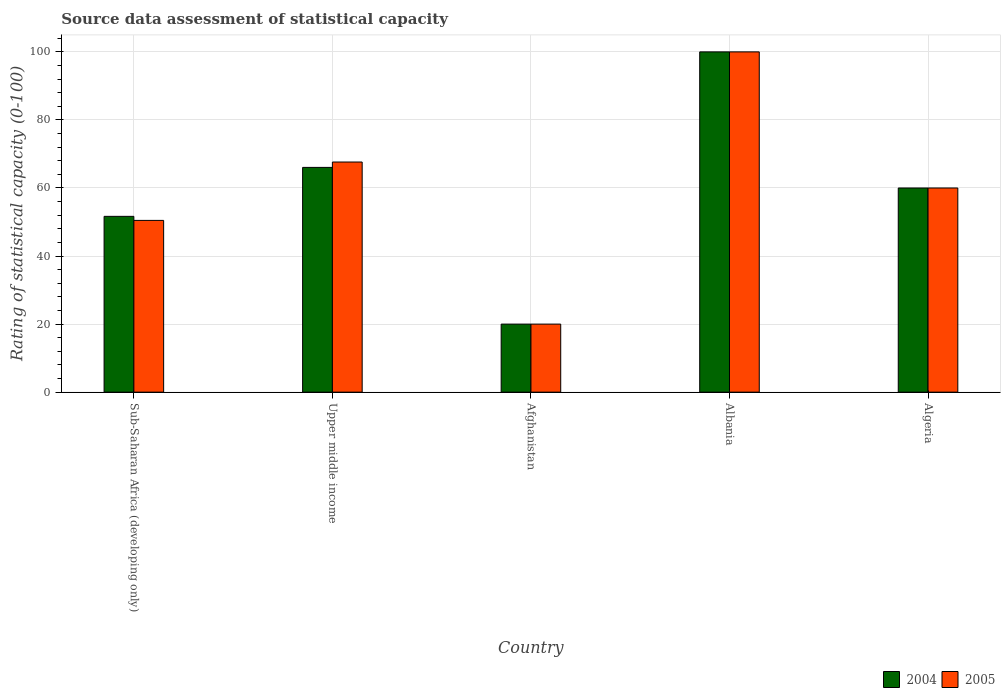How many bars are there on the 3rd tick from the left?
Your answer should be compact. 2. What is the label of the 4th group of bars from the left?
Ensure brevity in your answer.  Albania. What is the rating of statistical capacity in 2004 in Algeria?
Your response must be concise. 60. Across all countries, what is the maximum rating of statistical capacity in 2004?
Offer a terse response. 100. In which country was the rating of statistical capacity in 2004 maximum?
Make the answer very short. Albania. In which country was the rating of statistical capacity in 2005 minimum?
Offer a terse response. Afghanistan. What is the total rating of statistical capacity in 2004 in the graph?
Give a very brief answer. 297.72. What is the difference between the rating of statistical capacity in 2005 in Afghanistan and that in Algeria?
Your answer should be very brief. -40. What is the average rating of statistical capacity in 2004 per country?
Your answer should be compact. 59.54. In how many countries, is the rating of statistical capacity in 2005 greater than 12?
Provide a succinct answer. 5. What is the ratio of the rating of statistical capacity in 2005 in Afghanistan to that in Algeria?
Make the answer very short. 0.33. Is the difference between the rating of statistical capacity in 2005 in Sub-Saharan Africa (developing only) and Upper middle income greater than the difference between the rating of statistical capacity in 2004 in Sub-Saharan Africa (developing only) and Upper middle income?
Your response must be concise. No. What is the difference between the highest and the second highest rating of statistical capacity in 2004?
Offer a very short reply. -33.95. What is the difference between the highest and the lowest rating of statistical capacity in 2004?
Offer a terse response. 80. Is the sum of the rating of statistical capacity in 2004 in Algeria and Sub-Saharan Africa (developing only) greater than the maximum rating of statistical capacity in 2005 across all countries?
Ensure brevity in your answer.  Yes. What does the 1st bar from the left in Albania represents?
Keep it short and to the point. 2004. How many bars are there?
Ensure brevity in your answer.  10. How many countries are there in the graph?
Make the answer very short. 5. What is the difference between two consecutive major ticks on the Y-axis?
Give a very brief answer. 20. Does the graph contain grids?
Offer a very short reply. Yes. Where does the legend appear in the graph?
Keep it short and to the point. Bottom right. How are the legend labels stacked?
Your answer should be very brief. Horizontal. What is the title of the graph?
Keep it short and to the point. Source data assessment of statistical capacity. Does "1984" appear as one of the legend labels in the graph?
Ensure brevity in your answer.  No. What is the label or title of the X-axis?
Your answer should be compact. Country. What is the label or title of the Y-axis?
Keep it short and to the point. Rating of statistical capacity (0-100). What is the Rating of statistical capacity (0-100) of 2004 in Sub-Saharan Africa (developing only)?
Your answer should be very brief. 51.67. What is the Rating of statistical capacity (0-100) in 2005 in Sub-Saharan Africa (developing only)?
Offer a very short reply. 50.48. What is the Rating of statistical capacity (0-100) in 2004 in Upper middle income?
Provide a succinct answer. 66.05. What is the Rating of statistical capacity (0-100) in 2005 in Upper middle income?
Your answer should be very brief. 67.63. What is the Rating of statistical capacity (0-100) in 2004 in Afghanistan?
Your answer should be compact. 20. What is the Rating of statistical capacity (0-100) of 2005 in Afghanistan?
Offer a very short reply. 20. What is the Rating of statistical capacity (0-100) of 2004 in Algeria?
Make the answer very short. 60. Across all countries, what is the maximum Rating of statistical capacity (0-100) of 2004?
Ensure brevity in your answer.  100. Across all countries, what is the minimum Rating of statistical capacity (0-100) in 2004?
Offer a terse response. 20. Across all countries, what is the minimum Rating of statistical capacity (0-100) of 2005?
Your answer should be compact. 20. What is the total Rating of statistical capacity (0-100) in 2004 in the graph?
Provide a short and direct response. 297.72. What is the total Rating of statistical capacity (0-100) of 2005 in the graph?
Offer a terse response. 298.11. What is the difference between the Rating of statistical capacity (0-100) of 2004 in Sub-Saharan Africa (developing only) and that in Upper middle income?
Keep it short and to the point. -14.39. What is the difference between the Rating of statistical capacity (0-100) of 2005 in Sub-Saharan Africa (developing only) and that in Upper middle income?
Offer a terse response. -17.16. What is the difference between the Rating of statistical capacity (0-100) in 2004 in Sub-Saharan Africa (developing only) and that in Afghanistan?
Your answer should be compact. 31.67. What is the difference between the Rating of statistical capacity (0-100) of 2005 in Sub-Saharan Africa (developing only) and that in Afghanistan?
Offer a terse response. 30.48. What is the difference between the Rating of statistical capacity (0-100) of 2004 in Sub-Saharan Africa (developing only) and that in Albania?
Your response must be concise. -48.33. What is the difference between the Rating of statistical capacity (0-100) in 2005 in Sub-Saharan Africa (developing only) and that in Albania?
Provide a short and direct response. -49.52. What is the difference between the Rating of statistical capacity (0-100) in 2004 in Sub-Saharan Africa (developing only) and that in Algeria?
Your answer should be very brief. -8.33. What is the difference between the Rating of statistical capacity (0-100) in 2005 in Sub-Saharan Africa (developing only) and that in Algeria?
Provide a short and direct response. -9.52. What is the difference between the Rating of statistical capacity (0-100) in 2004 in Upper middle income and that in Afghanistan?
Give a very brief answer. 46.05. What is the difference between the Rating of statistical capacity (0-100) of 2005 in Upper middle income and that in Afghanistan?
Provide a succinct answer. 47.63. What is the difference between the Rating of statistical capacity (0-100) in 2004 in Upper middle income and that in Albania?
Keep it short and to the point. -33.95. What is the difference between the Rating of statistical capacity (0-100) in 2005 in Upper middle income and that in Albania?
Your response must be concise. -32.37. What is the difference between the Rating of statistical capacity (0-100) of 2004 in Upper middle income and that in Algeria?
Offer a very short reply. 6.05. What is the difference between the Rating of statistical capacity (0-100) of 2005 in Upper middle income and that in Algeria?
Keep it short and to the point. 7.63. What is the difference between the Rating of statistical capacity (0-100) in 2004 in Afghanistan and that in Albania?
Make the answer very short. -80. What is the difference between the Rating of statistical capacity (0-100) of 2005 in Afghanistan and that in Albania?
Keep it short and to the point. -80. What is the difference between the Rating of statistical capacity (0-100) of 2004 in Afghanistan and that in Algeria?
Keep it short and to the point. -40. What is the difference between the Rating of statistical capacity (0-100) in 2004 in Albania and that in Algeria?
Your answer should be very brief. 40. What is the difference between the Rating of statistical capacity (0-100) of 2005 in Albania and that in Algeria?
Your answer should be very brief. 40. What is the difference between the Rating of statistical capacity (0-100) in 2004 in Sub-Saharan Africa (developing only) and the Rating of statistical capacity (0-100) in 2005 in Upper middle income?
Your response must be concise. -15.96. What is the difference between the Rating of statistical capacity (0-100) of 2004 in Sub-Saharan Africa (developing only) and the Rating of statistical capacity (0-100) of 2005 in Afghanistan?
Give a very brief answer. 31.67. What is the difference between the Rating of statistical capacity (0-100) in 2004 in Sub-Saharan Africa (developing only) and the Rating of statistical capacity (0-100) in 2005 in Albania?
Your answer should be very brief. -48.33. What is the difference between the Rating of statistical capacity (0-100) of 2004 in Sub-Saharan Africa (developing only) and the Rating of statistical capacity (0-100) of 2005 in Algeria?
Offer a terse response. -8.33. What is the difference between the Rating of statistical capacity (0-100) of 2004 in Upper middle income and the Rating of statistical capacity (0-100) of 2005 in Afghanistan?
Keep it short and to the point. 46.05. What is the difference between the Rating of statistical capacity (0-100) in 2004 in Upper middle income and the Rating of statistical capacity (0-100) in 2005 in Albania?
Provide a succinct answer. -33.95. What is the difference between the Rating of statistical capacity (0-100) in 2004 in Upper middle income and the Rating of statistical capacity (0-100) in 2005 in Algeria?
Offer a terse response. 6.05. What is the difference between the Rating of statistical capacity (0-100) of 2004 in Afghanistan and the Rating of statistical capacity (0-100) of 2005 in Albania?
Keep it short and to the point. -80. What is the difference between the Rating of statistical capacity (0-100) of 2004 in Afghanistan and the Rating of statistical capacity (0-100) of 2005 in Algeria?
Provide a succinct answer. -40. What is the difference between the Rating of statistical capacity (0-100) of 2004 in Albania and the Rating of statistical capacity (0-100) of 2005 in Algeria?
Provide a succinct answer. 40. What is the average Rating of statistical capacity (0-100) in 2004 per country?
Your response must be concise. 59.54. What is the average Rating of statistical capacity (0-100) in 2005 per country?
Provide a short and direct response. 59.62. What is the difference between the Rating of statistical capacity (0-100) in 2004 and Rating of statistical capacity (0-100) in 2005 in Sub-Saharan Africa (developing only)?
Your answer should be compact. 1.19. What is the difference between the Rating of statistical capacity (0-100) in 2004 and Rating of statistical capacity (0-100) in 2005 in Upper middle income?
Your answer should be very brief. -1.58. What is the difference between the Rating of statistical capacity (0-100) in 2004 and Rating of statistical capacity (0-100) in 2005 in Afghanistan?
Your response must be concise. 0. What is the difference between the Rating of statistical capacity (0-100) of 2004 and Rating of statistical capacity (0-100) of 2005 in Albania?
Offer a terse response. 0. What is the ratio of the Rating of statistical capacity (0-100) of 2004 in Sub-Saharan Africa (developing only) to that in Upper middle income?
Give a very brief answer. 0.78. What is the ratio of the Rating of statistical capacity (0-100) in 2005 in Sub-Saharan Africa (developing only) to that in Upper middle income?
Offer a very short reply. 0.75. What is the ratio of the Rating of statistical capacity (0-100) of 2004 in Sub-Saharan Africa (developing only) to that in Afghanistan?
Ensure brevity in your answer.  2.58. What is the ratio of the Rating of statistical capacity (0-100) in 2005 in Sub-Saharan Africa (developing only) to that in Afghanistan?
Ensure brevity in your answer.  2.52. What is the ratio of the Rating of statistical capacity (0-100) in 2004 in Sub-Saharan Africa (developing only) to that in Albania?
Keep it short and to the point. 0.52. What is the ratio of the Rating of statistical capacity (0-100) of 2005 in Sub-Saharan Africa (developing only) to that in Albania?
Make the answer very short. 0.5. What is the ratio of the Rating of statistical capacity (0-100) of 2004 in Sub-Saharan Africa (developing only) to that in Algeria?
Make the answer very short. 0.86. What is the ratio of the Rating of statistical capacity (0-100) of 2005 in Sub-Saharan Africa (developing only) to that in Algeria?
Offer a very short reply. 0.84. What is the ratio of the Rating of statistical capacity (0-100) of 2004 in Upper middle income to that in Afghanistan?
Ensure brevity in your answer.  3.3. What is the ratio of the Rating of statistical capacity (0-100) of 2005 in Upper middle income to that in Afghanistan?
Provide a succinct answer. 3.38. What is the ratio of the Rating of statistical capacity (0-100) in 2004 in Upper middle income to that in Albania?
Offer a very short reply. 0.66. What is the ratio of the Rating of statistical capacity (0-100) of 2005 in Upper middle income to that in Albania?
Your answer should be compact. 0.68. What is the ratio of the Rating of statistical capacity (0-100) in 2004 in Upper middle income to that in Algeria?
Your response must be concise. 1.1. What is the ratio of the Rating of statistical capacity (0-100) in 2005 in Upper middle income to that in Algeria?
Offer a very short reply. 1.13. What is the ratio of the Rating of statistical capacity (0-100) of 2004 in Albania to that in Algeria?
Offer a terse response. 1.67. What is the difference between the highest and the second highest Rating of statistical capacity (0-100) in 2004?
Give a very brief answer. 33.95. What is the difference between the highest and the second highest Rating of statistical capacity (0-100) of 2005?
Keep it short and to the point. 32.37. What is the difference between the highest and the lowest Rating of statistical capacity (0-100) in 2005?
Your response must be concise. 80. 